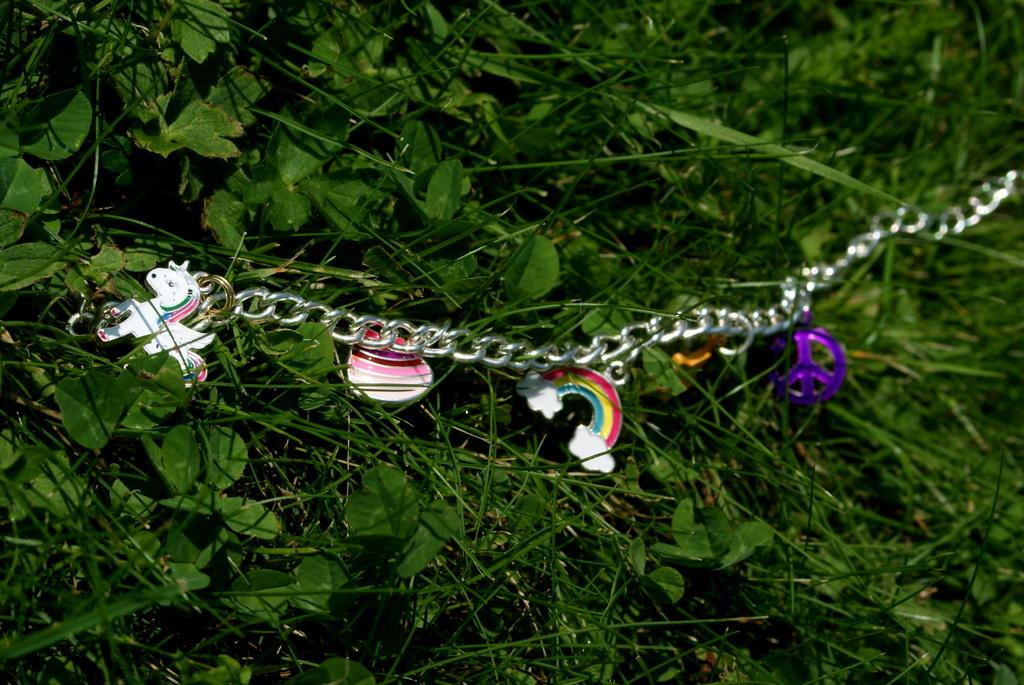What type of object is present in the image? There is a metal chain in the image. Are there any additional features on the metal chain? Yes, the metal chain has pendants. What can be seen in the background of the image? There are plants and grass in the background of the image. What flavor of mint can be seen growing in the image? There is no mint plant visible in the image; only plants and grass are present in the background. 